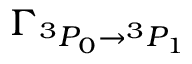<formula> <loc_0><loc_0><loc_500><loc_500>\Gamma _ ^ { 3 } P _ { 0 } ^ { 3 } P _ { 1 } }</formula> 